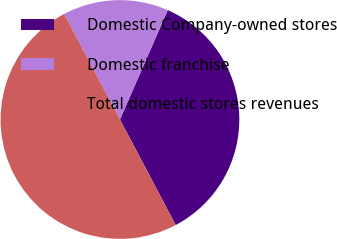Convert chart to OTSL. <chart><loc_0><loc_0><loc_500><loc_500><pie_chart><fcel>Domestic Company-owned stores<fcel>Domestic franchise<fcel>Total domestic stores revenues<nl><fcel>35.7%<fcel>14.3%<fcel>50.0%<nl></chart> 